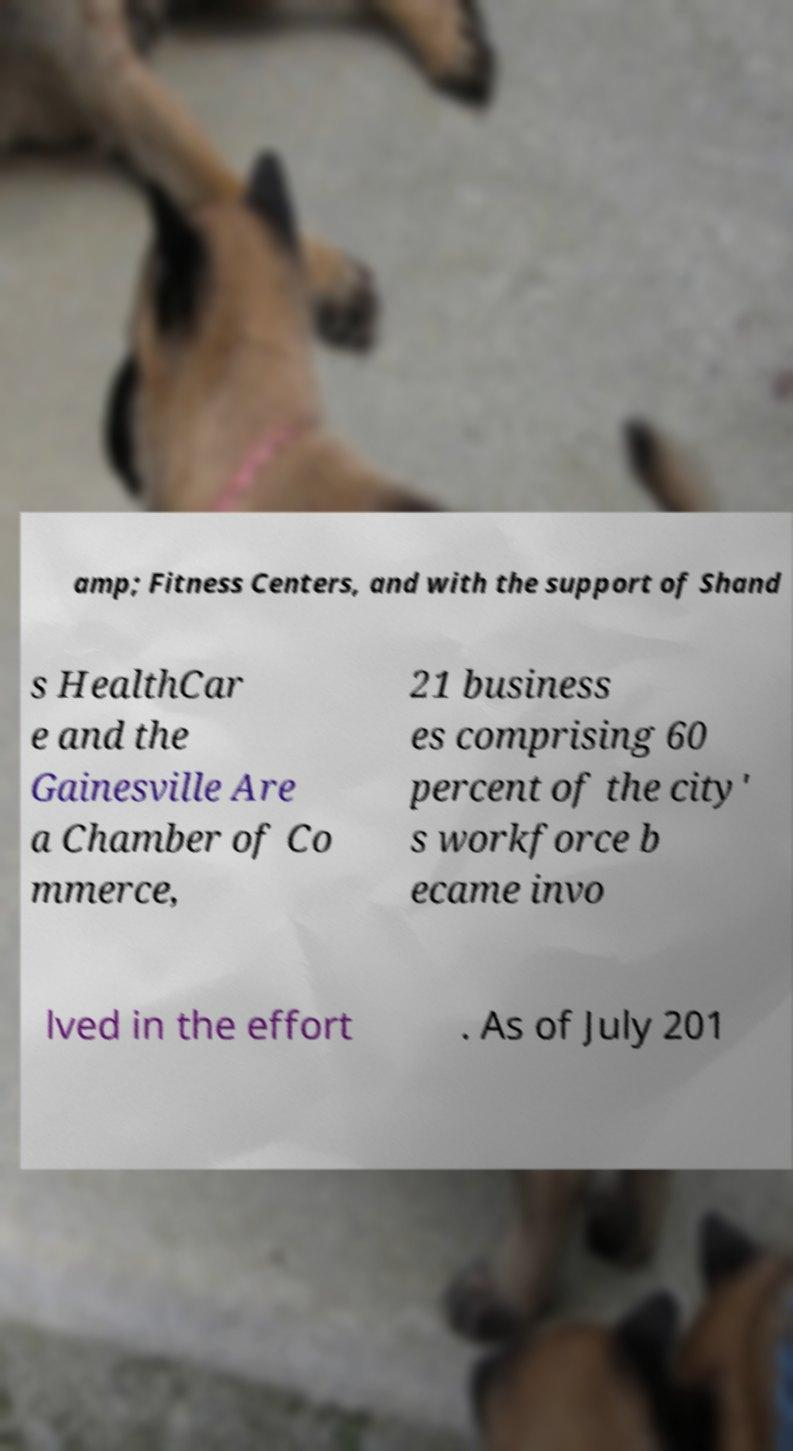Could you assist in decoding the text presented in this image and type it out clearly? amp; Fitness Centers, and with the support of Shand s HealthCar e and the Gainesville Are a Chamber of Co mmerce, 21 business es comprising 60 percent of the city' s workforce b ecame invo lved in the effort . As of July 201 